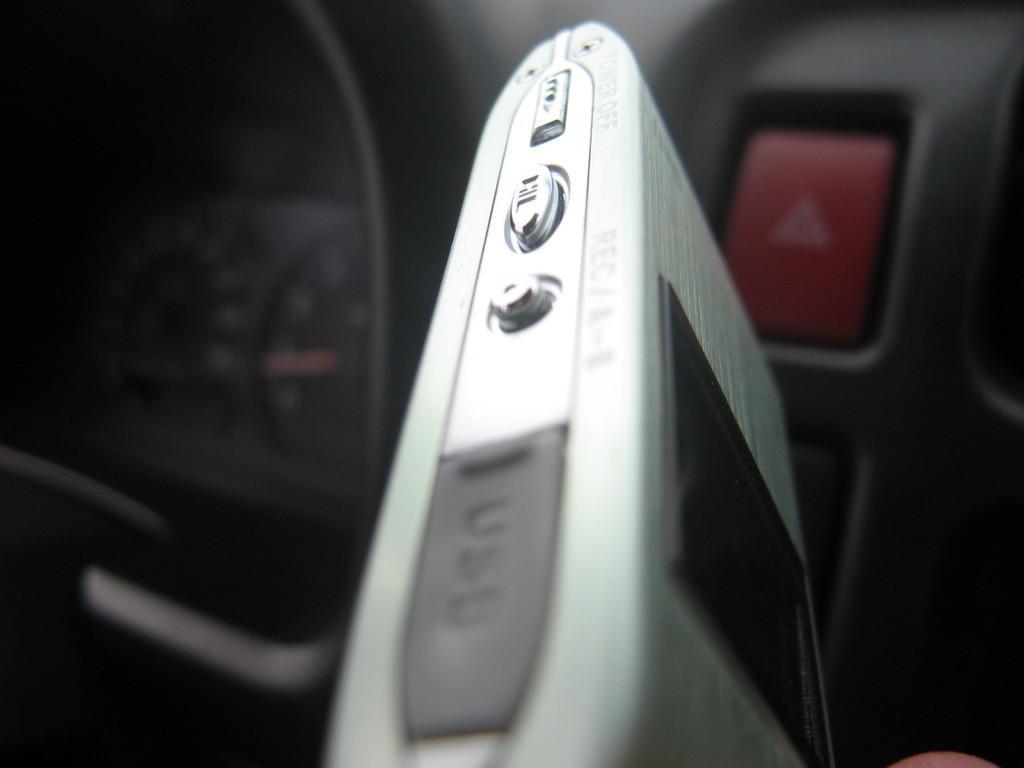Can you describe this image briefly? In this image I can see an electronic device and I can see the inner part of the vehicle. 